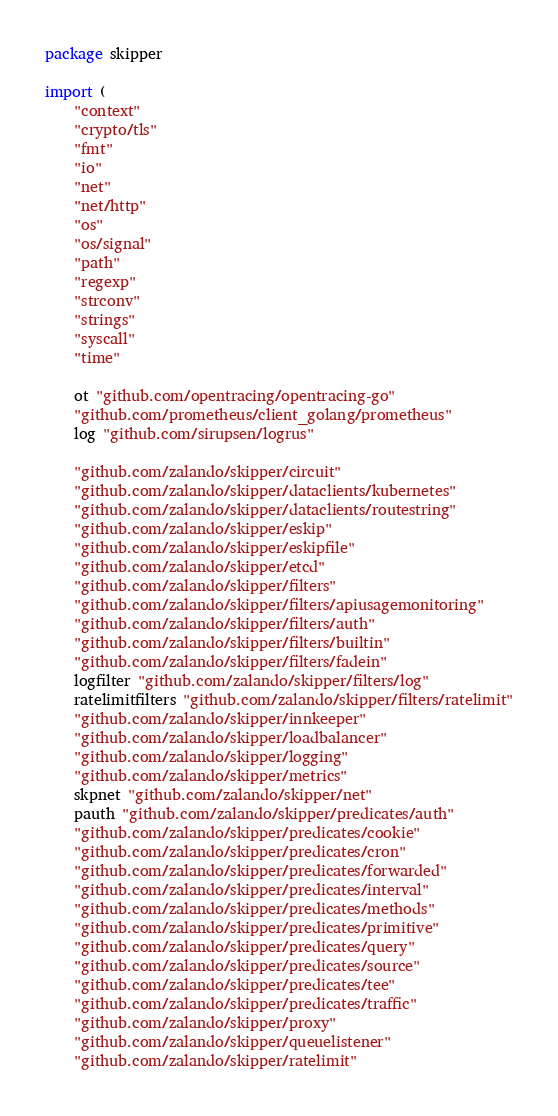Convert code to text. <code><loc_0><loc_0><loc_500><loc_500><_Go_>package skipper

import (
	"context"
	"crypto/tls"
	"fmt"
	"io"
	"net"
	"net/http"
	"os"
	"os/signal"
	"path"
	"regexp"
	"strconv"
	"strings"
	"syscall"
	"time"

	ot "github.com/opentracing/opentracing-go"
	"github.com/prometheus/client_golang/prometheus"
	log "github.com/sirupsen/logrus"

	"github.com/zalando/skipper/circuit"
	"github.com/zalando/skipper/dataclients/kubernetes"
	"github.com/zalando/skipper/dataclients/routestring"
	"github.com/zalando/skipper/eskip"
	"github.com/zalando/skipper/eskipfile"
	"github.com/zalando/skipper/etcd"
	"github.com/zalando/skipper/filters"
	"github.com/zalando/skipper/filters/apiusagemonitoring"
	"github.com/zalando/skipper/filters/auth"
	"github.com/zalando/skipper/filters/builtin"
	"github.com/zalando/skipper/filters/fadein"
	logfilter "github.com/zalando/skipper/filters/log"
	ratelimitfilters "github.com/zalando/skipper/filters/ratelimit"
	"github.com/zalando/skipper/innkeeper"
	"github.com/zalando/skipper/loadbalancer"
	"github.com/zalando/skipper/logging"
	"github.com/zalando/skipper/metrics"
	skpnet "github.com/zalando/skipper/net"
	pauth "github.com/zalando/skipper/predicates/auth"
	"github.com/zalando/skipper/predicates/cookie"
	"github.com/zalando/skipper/predicates/cron"
	"github.com/zalando/skipper/predicates/forwarded"
	"github.com/zalando/skipper/predicates/interval"
	"github.com/zalando/skipper/predicates/methods"
	"github.com/zalando/skipper/predicates/primitive"
	"github.com/zalando/skipper/predicates/query"
	"github.com/zalando/skipper/predicates/source"
	"github.com/zalando/skipper/predicates/tee"
	"github.com/zalando/skipper/predicates/traffic"
	"github.com/zalando/skipper/proxy"
	"github.com/zalando/skipper/queuelistener"
	"github.com/zalando/skipper/ratelimit"</code> 